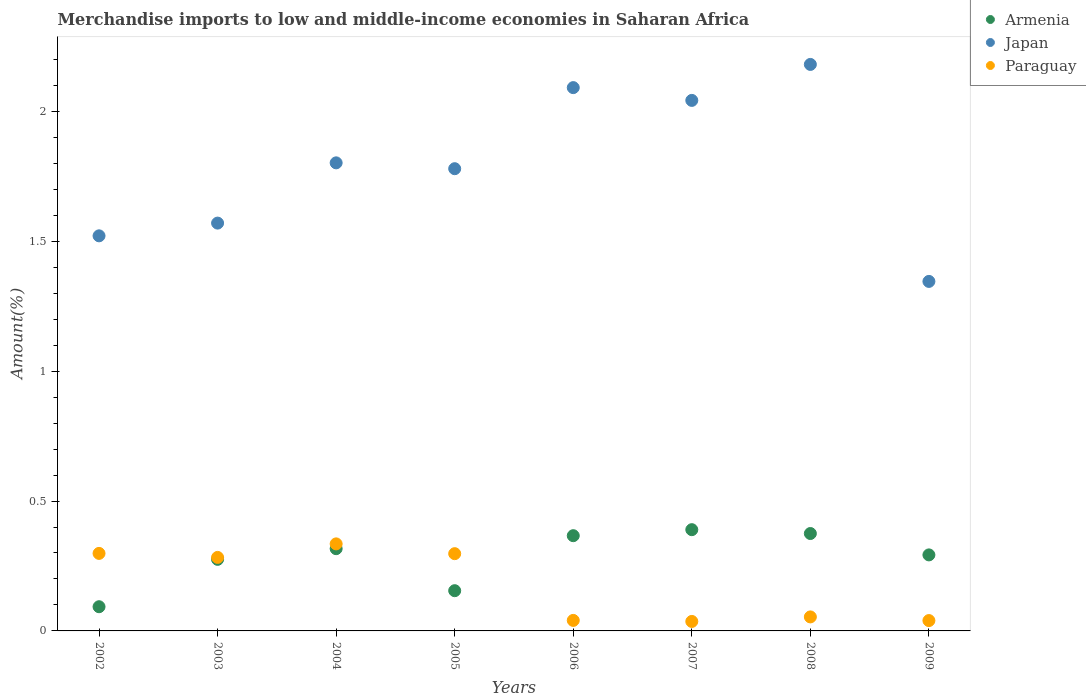What is the percentage of amount earned from merchandise imports in Armenia in 2005?
Keep it short and to the point. 0.15. Across all years, what is the maximum percentage of amount earned from merchandise imports in Armenia?
Your response must be concise. 0.39. Across all years, what is the minimum percentage of amount earned from merchandise imports in Armenia?
Ensure brevity in your answer.  0.09. In which year was the percentage of amount earned from merchandise imports in Japan maximum?
Provide a short and direct response. 2008. What is the total percentage of amount earned from merchandise imports in Armenia in the graph?
Provide a succinct answer. 2.26. What is the difference between the percentage of amount earned from merchandise imports in Armenia in 2004 and that in 2009?
Provide a short and direct response. 0.02. What is the difference between the percentage of amount earned from merchandise imports in Japan in 2004 and the percentage of amount earned from merchandise imports in Paraguay in 2003?
Ensure brevity in your answer.  1.52. What is the average percentage of amount earned from merchandise imports in Japan per year?
Offer a very short reply. 1.79. In the year 2006, what is the difference between the percentage of amount earned from merchandise imports in Japan and percentage of amount earned from merchandise imports in Armenia?
Offer a very short reply. 1.72. In how many years, is the percentage of amount earned from merchandise imports in Japan greater than 0.6 %?
Provide a short and direct response. 8. What is the ratio of the percentage of amount earned from merchandise imports in Armenia in 2002 to that in 2003?
Offer a terse response. 0.34. Is the percentage of amount earned from merchandise imports in Paraguay in 2003 less than that in 2006?
Offer a terse response. No. Is the difference between the percentage of amount earned from merchandise imports in Japan in 2004 and 2006 greater than the difference between the percentage of amount earned from merchandise imports in Armenia in 2004 and 2006?
Your answer should be compact. No. What is the difference between the highest and the second highest percentage of amount earned from merchandise imports in Japan?
Provide a short and direct response. 0.09. What is the difference between the highest and the lowest percentage of amount earned from merchandise imports in Japan?
Ensure brevity in your answer.  0.84. Is it the case that in every year, the sum of the percentage of amount earned from merchandise imports in Paraguay and percentage of amount earned from merchandise imports in Japan  is greater than the percentage of amount earned from merchandise imports in Armenia?
Ensure brevity in your answer.  Yes. Is the percentage of amount earned from merchandise imports in Japan strictly less than the percentage of amount earned from merchandise imports in Paraguay over the years?
Keep it short and to the point. No. How many years are there in the graph?
Give a very brief answer. 8. What is the title of the graph?
Offer a terse response. Merchandise imports to low and middle-income economies in Saharan Africa. What is the label or title of the Y-axis?
Ensure brevity in your answer.  Amount(%). What is the Amount(%) in Armenia in 2002?
Make the answer very short. 0.09. What is the Amount(%) in Japan in 2002?
Your answer should be compact. 1.52. What is the Amount(%) in Paraguay in 2002?
Keep it short and to the point. 0.3. What is the Amount(%) in Armenia in 2003?
Provide a short and direct response. 0.28. What is the Amount(%) in Japan in 2003?
Your answer should be compact. 1.57. What is the Amount(%) in Paraguay in 2003?
Your answer should be compact. 0.28. What is the Amount(%) in Armenia in 2004?
Offer a terse response. 0.32. What is the Amount(%) of Japan in 2004?
Provide a short and direct response. 1.8. What is the Amount(%) in Paraguay in 2004?
Your response must be concise. 0.34. What is the Amount(%) in Armenia in 2005?
Your answer should be very brief. 0.15. What is the Amount(%) in Japan in 2005?
Provide a succinct answer. 1.78. What is the Amount(%) in Paraguay in 2005?
Provide a succinct answer. 0.3. What is the Amount(%) in Armenia in 2006?
Ensure brevity in your answer.  0.37. What is the Amount(%) of Japan in 2006?
Your response must be concise. 2.09. What is the Amount(%) of Paraguay in 2006?
Your answer should be very brief. 0.04. What is the Amount(%) of Armenia in 2007?
Make the answer very short. 0.39. What is the Amount(%) in Japan in 2007?
Provide a succinct answer. 2.04. What is the Amount(%) in Paraguay in 2007?
Offer a very short reply. 0.04. What is the Amount(%) of Armenia in 2008?
Offer a terse response. 0.37. What is the Amount(%) of Japan in 2008?
Your answer should be compact. 2.18. What is the Amount(%) in Paraguay in 2008?
Provide a short and direct response. 0.05. What is the Amount(%) in Armenia in 2009?
Your answer should be very brief. 0.29. What is the Amount(%) of Japan in 2009?
Give a very brief answer. 1.35. What is the Amount(%) in Paraguay in 2009?
Give a very brief answer. 0.04. Across all years, what is the maximum Amount(%) in Armenia?
Give a very brief answer. 0.39. Across all years, what is the maximum Amount(%) in Japan?
Your answer should be very brief. 2.18. Across all years, what is the maximum Amount(%) of Paraguay?
Provide a succinct answer. 0.34. Across all years, what is the minimum Amount(%) of Armenia?
Ensure brevity in your answer.  0.09. Across all years, what is the minimum Amount(%) of Japan?
Make the answer very short. 1.35. Across all years, what is the minimum Amount(%) in Paraguay?
Provide a short and direct response. 0.04. What is the total Amount(%) of Armenia in the graph?
Provide a short and direct response. 2.26. What is the total Amount(%) in Japan in the graph?
Offer a very short reply. 14.33. What is the total Amount(%) in Paraguay in the graph?
Your answer should be compact. 1.38. What is the difference between the Amount(%) of Armenia in 2002 and that in 2003?
Your answer should be compact. -0.18. What is the difference between the Amount(%) in Japan in 2002 and that in 2003?
Give a very brief answer. -0.05. What is the difference between the Amount(%) of Paraguay in 2002 and that in 2003?
Provide a succinct answer. 0.02. What is the difference between the Amount(%) of Armenia in 2002 and that in 2004?
Your answer should be compact. -0.22. What is the difference between the Amount(%) of Japan in 2002 and that in 2004?
Offer a terse response. -0.28. What is the difference between the Amount(%) of Paraguay in 2002 and that in 2004?
Keep it short and to the point. -0.04. What is the difference between the Amount(%) in Armenia in 2002 and that in 2005?
Provide a succinct answer. -0.06. What is the difference between the Amount(%) of Japan in 2002 and that in 2005?
Keep it short and to the point. -0.26. What is the difference between the Amount(%) in Armenia in 2002 and that in 2006?
Give a very brief answer. -0.27. What is the difference between the Amount(%) of Japan in 2002 and that in 2006?
Provide a short and direct response. -0.57. What is the difference between the Amount(%) of Paraguay in 2002 and that in 2006?
Provide a short and direct response. 0.26. What is the difference between the Amount(%) of Armenia in 2002 and that in 2007?
Offer a very short reply. -0.3. What is the difference between the Amount(%) of Japan in 2002 and that in 2007?
Ensure brevity in your answer.  -0.52. What is the difference between the Amount(%) of Paraguay in 2002 and that in 2007?
Make the answer very short. 0.26. What is the difference between the Amount(%) in Armenia in 2002 and that in 2008?
Make the answer very short. -0.28. What is the difference between the Amount(%) in Japan in 2002 and that in 2008?
Make the answer very short. -0.66. What is the difference between the Amount(%) in Paraguay in 2002 and that in 2008?
Provide a succinct answer. 0.24. What is the difference between the Amount(%) in Armenia in 2002 and that in 2009?
Give a very brief answer. -0.2. What is the difference between the Amount(%) of Japan in 2002 and that in 2009?
Your answer should be compact. 0.18. What is the difference between the Amount(%) of Paraguay in 2002 and that in 2009?
Make the answer very short. 0.26. What is the difference between the Amount(%) of Armenia in 2003 and that in 2004?
Offer a terse response. -0.04. What is the difference between the Amount(%) of Japan in 2003 and that in 2004?
Your answer should be very brief. -0.23. What is the difference between the Amount(%) in Paraguay in 2003 and that in 2004?
Offer a very short reply. -0.05. What is the difference between the Amount(%) in Armenia in 2003 and that in 2005?
Keep it short and to the point. 0.12. What is the difference between the Amount(%) of Japan in 2003 and that in 2005?
Provide a short and direct response. -0.21. What is the difference between the Amount(%) of Paraguay in 2003 and that in 2005?
Your answer should be very brief. -0.01. What is the difference between the Amount(%) of Armenia in 2003 and that in 2006?
Ensure brevity in your answer.  -0.09. What is the difference between the Amount(%) of Japan in 2003 and that in 2006?
Ensure brevity in your answer.  -0.52. What is the difference between the Amount(%) in Paraguay in 2003 and that in 2006?
Ensure brevity in your answer.  0.24. What is the difference between the Amount(%) in Armenia in 2003 and that in 2007?
Keep it short and to the point. -0.11. What is the difference between the Amount(%) of Japan in 2003 and that in 2007?
Keep it short and to the point. -0.47. What is the difference between the Amount(%) in Paraguay in 2003 and that in 2007?
Give a very brief answer. 0.25. What is the difference between the Amount(%) in Armenia in 2003 and that in 2008?
Provide a short and direct response. -0.1. What is the difference between the Amount(%) of Japan in 2003 and that in 2008?
Give a very brief answer. -0.61. What is the difference between the Amount(%) in Paraguay in 2003 and that in 2008?
Give a very brief answer. 0.23. What is the difference between the Amount(%) of Armenia in 2003 and that in 2009?
Ensure brevity in your answer.  -0.02. What is the difference between the Amount(%) in Japan in 2003 and that in 2009?
Offer a very short reply. 0.22. What is the difference between the Amount(%) in Paraguay in 2003 and that in 2009?
Provide a short and direct response. 0.24. What is the difference between the Amount(%) in Armenia in 2004 and that in 2005?
Offer a terse response. 0.16. What is the difference between the Amount(%) of Japan in 2004 and that in 2005?
Your response must be concise. 0.02. What is the difference between the Amount(%) of Paraguay in 2004 and that in 2005?
Keep it short and to the point. 0.04. What is the difference between the Amount(%) in Armenia in 2004 and that in 2006?
Your answer should be very brief. -0.05. What is the difference between the Amount(%) in Japan in 2004 and that in 2006?
Provide a succinct answer. -0.29. What is the difference between the Amount(%) of Paraguay in 2004 and that in 2006?
Your answer should be compact. 0.29. What is the difference between the Amount(%) of Armenia in 2004 and that in 2007?
Provide a short and direct response. -0.07. What is the difference between the Amount(%) in Japan in 2004 and that in 2007?
Offer a terse response. -0.24. What is the difference between the Amount(%) of Paraguay in 2004 and that in 2007?
Offer a very short reply. 0.3. What is the difference between the Amount(%) of Armenia in 2004 and that in 2008?
Offer a terse response. -0.06. What is the difference between the Amount(%) in Japan in 2004 and that in 2008?
Your response must be concise. -0.38. What is the difference between the Amount(%) in Paraguay in 2004 and that in 2008?
Provide a short and direct response. 0.28. What is the difference between the Amount(%) of Armenia in 2004 and that in 2009?
Give a very brief answer. 0.02. What is the difference between the Amount(%) in Japan in 2004 and that in 2009?
Give a very brief answer. 0.46. What is the difference between the Amount(%) of Paraguay in 2004 and that in 2009?
Offer a terse response. 0.3. What is the difference between the Amount(%) in Armenia in 2005 and that in 2006?
Offer a very short reply. -0.21. What is the difference between the Amount(%) of Japan in 2005 and that in 2006?
Your answer should be very brief. -0.31. What is the difference between the Amount(%) in Paraguay in 2005 and that in 2006?
Provide a succinct answer. 0.26. What is the difference between the Amount(%) of Armenia in 2005 and that in 2007?
Keep it short and to the point. -0.23. What is the difference between the Amount(%) of Japan in 2005 and that in 2007?
Provide a short and direct response. -0.26. What is the difference between the Amount(%) of Paraguay in 2005 and that in 2007?
Make the answer very short. 0.26. What is the difference between the Amount(%) in Armenia in 2005 and that in 2008?
Give a very brief answer. -0.22. What is the difference between the Amount(%) in Japan in 2005 and that in 2008?
Make the answer very short. -0.4. What is the difference between the Amount(%) in Paraguay in 2005 and that in 2008?
Ensure brevity in your answer.  0.24. What is the difference between the Amount(%) in Armenia in 2005 and that in 2009?
Give a very brief answer. -0.14. What is the difference between the Amount(%) in Japan in 2005 and that in 2009?
Make the answer very short. 0.43. What is the difference between the Amount(%) of Paraguay in 2005 and that in 2009?
Provide a short and direct response. 0.26. What is the difference between the Amount(%) in Armenia in 2006 and that in 2007?
Offer a very short reply. -0.02. What is the difference between the Amount(%) in Japan in 2006 and that in 2007?
Provide a succinct answer. 0.05. What is the difference between the Amount(%) in Paraguay in 2006 and that in 2007?
Keep it short and to the point. 0. What is the difference between the Amount(%) in Armenia in 2006 and that in 2008?
Your response must be concise. -0.01. What is the difference between the Amount(%) of Japan in 2006 and that in 2008?
Your answer should be compact. -0.09. What is the difference between the Amount(%) in Paraguay in 2006 and that in 2008?
Ensure brevity in your answer.  -0.01. What is the difference between the Amount(%) in Armenia in 2006 and that in 2009?
Offer a terse response. 0.07. What is the difference between the Amount(%) in Japan in 2006 and that in 2009?
Ensure brevity in your answer.  0.75. What is the difference between the Amount(%) of Paraguay in 2006 and that in 2009?
Keep it short and to the point. 0. What is the difference between the Amount(%) of Armenia in 2007 and that in 2008?
Offer a very short reply. 0.01. What is the difference between the Amount(%) in Japan in 2007 and that in 2008?
Give a very brief answer. -0.14. What is the difference between the Amount(%) of Paraguay in 2007 and that in 2008?
Provide a succinct answer. -0.02. What is the difference between the Amount(%) in Armenia in 2007 and that in 2009?
Give a very brief answer. 0.1. What is the difference between the Amount(%) in Japan in 2007 and that in 2009?
Your answer should be very brief. 0.7. What is the difference between the Amount(%) in Paraguay in 2007 and that in 2009?
Ensure brevity in your answer.  -0. What is the difference between the Amount(%) of Armenia in 2008 and that in 2009?
Ensure brevity in your answer.  0.08. What is the difference between the Amount(%) in Japan in 2008 and that in 2009?
Keep it short and to the point. 0.84. What is the difference between the Amount(%) in Paraguay in 2008 and that in 2009?
Make the answer very short. 0.01. What is the difference between the Amount(%) in Armenia in 2002 and the Amount(%) in Japan in 2003?
Give a very brief answer. -1.48. What is the difference between the Amount(%) of Armenia in 2002 and the Amount(%) of Paraguay in 2003?
Provide a succinct answer. -0.19. What is the difference between the Amount(%) of Japan in 2002 and the Amount(%) of Paraguay in 2003?
Offer a very short reply. 1.24. What is the difference between the Amount(%) of Armenia in 2002 and the Amount(%) of Japan in 2004?
Make the answer very short. -1.71. What is the difference between the Amount(%) in Armenia in 2002 and the Amount(%) in Paraguay in 2004?
Offer a very short reply. -0.24. What is the difference between the Amount(%) in Japan in 2002 and the Amount(%) in Paraguay in 2004?
Your answer should be very brief. 1.19. What is the difference between the Amount(%) of Armenia in 2002 and the Amount(%) of Japan in 2005?
Your answer should be compact. -1.69. What is the difference between the Amount(%) of Armenia in 2002 and the Amount(%) of Paraguay in 2005?
Keep it short and to the point. -0.2. What is the difference between the Amount(%) in Japan in 2002 and the Amount(%) in Paraguay in 2005?
Keep it short and to the point. 1.22. What is the difference between the Amount(%) of Armenia in 2002 and the Amount(%) of Japan in 2006?
Offer a terse response. -2. What is the difference between the Amount(%) of Armenia in 2002 and the Amount(%) of Paraguay in 2006?
Offer a terse response. 0.05. What is the difference between the Amount(%) in Japan in 2002 and the Amount(%) in Paraguay in 2006?
Make the answer very short. 1.48. What is the difference between the Amount(%) in Armenia in 2002 and the Amount(%) in Japan in 2007?
Your answer should be compact. -1.95. What is the difference between the Amount(%) of Armenia in 2002 and the Amount(%) of Paraguay in 2007?
Make the answer very short. 0.06. What is the difference between the Amount(%) in Japan in 2002 and the Amount(%) in Paraguay in 2007?
Offer a very short reply. 1.48. What is the difference between the Amount(%) of Armenia in 2002 and the Amount(%) of Japan in 2008?
Provide a short and direct response. -2.09. What is the difference between the Amount(%) in Armenia in 2002 and the Amount(%) in Paraguay in 2008?
Give a very brief answer. 0.04. What is the difference between the Amount(%) in Japan in 2002 and the Amount(%) in Paraguay in 2008?
Your response must be concise. 1.47. What is the difference between the Amount(%) of Armenia in 2002 and the Amount(%) of Japan in 2009?
Your answer should be compact. -1.25. What is the difference between the Amount(%) in Armenia in 2002 and the Amount(%) in Paraguay in 2009?
Offer a terse response. 0.05. What is the difference between the Amount(%) of Japan in 2002 and the Amount(%) of Paraguay in 2009?
Offer a terse response. 1.48. What is the difference between the Amount(%) in Armenia in 2003 and the Amount(%) in Japan in 2004?
Give a very brief answer. -1.53. What is the difference between the Amount(%) in Armenia in 2003 and the Amount(%) in Paraguay in 2004?
Offer a terse response. -0.06. What is the difference between the Amount(%) of Japan in 2003 and the Amount(%) of Paraguay in 2004?
Provide a short and direct response. 1.23. What is the difference between the Amount(%) of Armenia in 2003 and the Amount(%) of Japan in 2005?
Offer a terse response. -1.5. What is the difference between the Amount(%) of Armenia in 2003 and the Amount(%) of Paraguay in 2005?
Your response must be concise. -0.02. What is the difference between the Amount(%) in Japan in 2003 and the Amount(%) in Paraguay in 2005?
Keep it short and to the point. 1.27. What is the difference between the Amount(%) of Armenia in 2003 and the Amount(%) of Japan in 2006?
Your answer should be compact. -1.82. What is the difference between the Amount(%) in Armenia in 2003 and the Amount(%) in Paraguay in 2006?
Ensure brevity in your answer.  0.23. What is the difference between the Amount(%) in Japan in 2003 and the Amount(%) in Paraguay in 2006?
Give a very brief answer. 1.53. What is the difference between the Amount(%) in Armenia in 2003 and the Amount(%) in Japan in 2007?
Offer a very short reply. -1.77. What is the difference between the Amount(%) in Armenia in 2003 and the Amount(%) in Paraguay in 2007?
Your response must be concise. 0.24. What is the difference between the Amount(%) of Japan in 2003 and the Amount(%) of Paraguay in 2007?
Your answer should be very brief. 1.53. What is the difference between the Amount(%) of Armenia in 2003 and the Amount(%) of Japan in 2008?
Your answer should be very brief. -1.91. What is the difference between the Amount(%) in Armenia in 2003 and the Amount(%) in Paraguay in 2008?
Provide a succinct answer. 0.22. What is the difference between the Amount(%) in Japan in 2003 and the Amount(%) in Paraguay in 2008?
Your answer should be compact. 1.52. What is the difference between the Amount(%) in Armenia in 2003 and the Amount(%) in Japan in 2009?
Offer a terse response. -1.07. What is the difference between the Amount(%) in Armenia in 2003 and the Amount(%) in Paraguay in 2009?
Keep it short and to the point. 0.24. What is the difference between the Amount(%) in Japan in 2003 and the Amount(%) in Paraguay in 2009?
Give a very brief answer. 1.53. What is the difference between the Amount(%) in Armenia in 2004 and the Amount(%) in Japan in 2005?
Your response must be concise. -1.46. What is the difference between the Amount(%) of Armenia in 2004 and the Amount(%) of Paraguay in 2005?
Give a very brief answer. 0.02. What is the difference between the Amount(%) in Japan in 2004 and the Amount(%) in Paraguay in 2005?
Your answer should be very brief. 1.5. What is the difference between the Amount(%) in Armenia in 2004 and the Amount(%) in Japan in 2006?
Provide a short and direct response. -1.77. What is the difference between the Amount(%) of Armenia in 2004 and the Amount(%) of Paraguay in 2006?
Offer a very short reply. 0.28. What is the difference between the Amount(%) in Japan in 2004 and the Amount(%) in Paraguay in 2006?
Ensure brevity in your answer.  1.76. What is the difference between the Amount(%) of Armenia in 2004 and the Amount(%) of Japan in 2007?
Provide a short and direct response. -1.73. What is the difference between the Amount(%) of Armenia in 2004 and the Amount(%) of Paraguay in 2007?
Keep it short and to the point. 0.28. What is the difference between the Amount(%) of Japan in 2004 and the Amount(%) of Paraguay in 2007?
Your answer should be compact. 1.77. What is the difference between the Amount(%) in Armenia in 2004 and the Amount(%) in Japan in 2008?
Make the answer very short. -1.86. What is the difference between the Amount(%) in Armenia in 2004 and the Amount(%) in Paraguay in 2008?
Your answer should be very brief. 0.26. What is the difference between the Amount(%) in Japan in 2004 and the Amount(%) in Paraguay in 2008?
Make the answer very short. 1.75. What is the difference between the Amount(%) in Armenia in 2004 and the Amount(%) in Japan in 2009?
Keep it short and to the point. -1.03. What is the difference between the Amount(%) in Armenia in 2004 and the Amount(%) in Paraguay in 2009?
Ensure brevity in your answer.  0.28. What is the difference between the Amount(%) in Japan in 2004 and the Amount(%) in Paraguay in 2009?
Your response must be concise. 1.76. What is the difference between the Amount(%) in Armenia in 2005 and the Amount(%) in Japan in 2006?
Your response must be concise. -1.94. What is the difference between the Amount(%) of Armenia in 2005 and the Amount(%) of Paraguay in 2006?
Your answer should be very brief. 0.11. What is the difference between the Amount(%) of Japan in 2005 and the Amount(%) of Paraguay in 2006?
Ensure brevity in your answer.  1.74. What is the difference between the Amount(%) in Armenia in 2005 and the Amount(%) in Japan in 2007?
Offer a terse response. -1.89. What is the difference between the Amount(%) in Armenia in 2005 and the Amount(%) in Paraguay in 2007?
Your answer should be very brief. 0.12. What is the difference between the Amount(%) in Japan in 2005 and the Amount(%) in Paraguay in 2007?
Offer a terse response. 1.74. What is the difference between the Amount(%) in Armenia in 2005 and the Amount(%) in Japan in 2008?
Your answer should be very brief. -2.03. What is the difference between the Amount(%) in Armenia in 2005 and the Amount(%) in Paraguay in 2008?
Provide a succinct answer. 0.1. What is the difference between the Amount(%) in Japan in 2005 and the Amount(%) in Paraguay in 2008?
Your answer should be compact. 1.73. What is the difference between the Amount(%) in Armenia in 2005 and the Amount(%) in Japan in 2009?
Give a very brief answer. -1.19. What is the difference between the Amount(%) in Armenia in 2005 and the Amount(%) in Paraguay in 2009?
Give a very brief answer. 0.12. What is the difference between the Amount(%) of Japan in 2005 and the Amount(%) of Paraguay in 2009?
Ensure brevity in your answer.  1.74. What is the difference between the Amount(%) in Armenia in 2006 and the Amount(%) in Japan in 2007?
Your answer should be very brief. -1.68. What is the difference between the Amount(%) of Armenia in 2006 and the Amount(%) of Paraguay in 2007?
Provide a short and direct response. 0.33. What is the difference between the Amount(%) of Japan in 2006 and the Amount(%) of Paraguay in 2007?
Offer a very short reply. 2.05. What is the difference between the Amount(%) of Armenia in 2006 and the Amount(%) of Japan in 2008?
Your response must be concise. -1.81. What is the difference between the Amount(%) of Armenia in 2006 and the Amount(%) of Paraguay in 2008?
Provide a short and direct response. 0.31. What is the difference between the Amount(%) of Japan in 2006 and the Amount(%) of Paraguay in 2008?
Give a very brief answer. 2.04. What is the difference between the Amount(%) in Armenia in 2006 and the Amount(%) in Japan in 2009?
Your answer should be very brief. -0.98. What is the difference between the Amount(%) in Armenia in 2006 and the Amount(%) in Paraguay in 2009?
Offer a very short reply. 0.33. What is the difference between the Amount(%) of Japan in 2006 and the Amount(%) of Paraguay in 2009?
Make the answer very short. 2.05. What is the difference between the Amount(%) in Armenia in 2007 and the Amount(%) in Japan in 2008?
Your answer should be very brief. -1.79. What is the difference between the Amount(%) of Armenia in 2007 and the Amount(%) of Paraguay in 2008?
Provide a succinct answer. 0.34. What is the difference between the Amount(%) in Japan in 2007 and the Amount(%) in Paraguay in 2008?
Make the answer very short. 1.99. What is the difference between the Amount(%) of Armenia in 2007 and the Amount(%) of Japan in 2009?
Offer a very short reply. -0.96. What is the difference between the Amount(%) in Armenia in 2007 and the Amount(%) in Paraguay in 2009?
Your answer should be very brief. 0.35. What is the difference between the Amount(%) in Japan in 2007 and the Amount(%) in Paraguay in 2009?
Keep it short and to the point. 2. What is the difference between the Amount(%) of Armenia in 2008 and the Amount(%) of Japan in 2009?
Offer a terse response. -0.97. What is the difference between the Amount(%) in Armenia in 2008 and the Amount(%) in Paraguay in 2009?
Provide a succinct answer. 0.34. What is the difference between the Amount(%) in Japan in 2008 and the Amount(%) in Paraguay in 2009?
Make the answer very short. 2.14. What is the average Amount(%) of Armenia per year?
Offer a terse response. 0.28. What is the average Amount(%) in Japan per year?
Provide a succinct answer. 1.79. What is the average Amount(%) in Paraguay per year?
Ensure brevity in your answer.  0.17. In the year 2002, what is the difference between the Amount(%) in Armenia and Amount(%) in Japan?
Provide a succinct answer. -1.43. In the year 2002, what is the difference between the Amount(%) of Armenia and Amount(%) of Paraguay?
Offer a terse response. -0.21. In the year 2002, what is the difference between the Amount(%) in Japan and Amount(%) in Paraguay?
Give a very brief answer. 1.22. In the year 2003, what is the difference between the Amount(%) of Armenia and Amount(%) of Japan?
Offer a terse response. -1.29. In the year 2003, what is the difference between the Amount(%) of Armenia and Amount(%) of Paraguay?
Ensure brevity in your answer.  -0.01. In the year 2003, what is the difference between the Amount(%) in Japan and Amount(%) in Paraguay?
Keep it short and to the point. 1.29. In the year 2004, what is the difference between the Amount(%) in Armenia and Amount(%) in Japan?
Your answer should be compact. -1.49. In the year 2004, what is the difference between the Amount(%) in Armenia and Amount(%) in Paraguay?
Your answer should be very brief. -0.02. In the year 2004, what is the difference between the Amount(%) of Japan and Amount(%) of Paraguay?
Provide a short and direct response. 1.47. In the year 2005, what is the difference between the Amount(%) in Armenia and Amount(%) in Japan?
Your response must be concise. -1.62. In the year 2005, what is the difference between the Amount(%) of Armenia and Amount(%) of Paraguay?
Provide a short and direct response. -0.14. In the year 2005, what is the difference between the Amount(%) in Japan and Amount(%) in Paraguay?
Offer a terse response. 1.48. In the year 2006, what is the difference between the Amount(%) of Armenia and Amount(%) of Japan?
Provide a succinct answer. -1.72. In the year 2006, what is the difference between the Amount(%) of Armenia and Amount(%) of Paraguay?
Ensure brevity in your answer.  0.33. In the year 2006, what is the difference between the Amount(%) of Japan and Amount(%) of Paraguay?
Your answer should be compact. 2.05. In the year 2007, what is the difference between the Amount(%) of Armenia and Amount(%) of Japan?
Provide a short and direct response. -1.65. In the year 2007, what is the difference between the Amount(%) of Armenia and Amount(%) of Paraguay?
Your answer should be very brief. 0.35. In the year 2007, what is the difference between the Amount(%) in Japan and Amount(%) in Paraguay?
Offer a terse response. 2.01. In the year 2008, what is the difference between the Amount(%) in Armenia and Amount(%) in Japan?
Your response must be concise. -1.81. In the year 2008, what is the difference between the Amount(%) of Armenia and Amount(%) of Paraguay?
Offer a very short reply. 0.32. In the year 2008, what is the difference between the Amount(%) in Japan and Amount(%) in Paraguay?
Give a very brief answer. 2.13. In the year 2009, what is the difference between the Amount(%) in Armenia and Amount(%) in Japan?
Ensure brevity in your answer.  -1.05. In the year 2009, what is the difference between the Amount(%) of Armenia and Amount(%) of Paraguay?
Provide a succinct answer. 0.25. In the year 2009, what is the difference between the Amount(%) in Japan and Amount(%) in Paraguay?
Make the answer very short. 1.31. What is the ratio of the Amount(%) of Armenia in 2002 to that in 2003?
Ensure brevity in your answer.  0.34. What is the ratio of the Amount(%) in Japan in 2002 to that in 2003?
Offer a terse response. 0.97. What is the ratio of the Amount(%) in Paraguay in 2002 to that in 2003?
Offer a terse response. 1.05. What is the ratio of the Amount(%) in Armenia in 2002 to that in 2004?
Ensure brevity in your answer.  0.29. What is the ratio of the Amount(%) of Japan in 2002 to that in 2004?
Provide a succinct answer. 0.84. What is the ratio of the Amount(%) of Paraguay in 2002 to that in 2004?
Offer a terse response. 0.89. What is the ratio of the Amount(%) in Armenia in 2002 to that in 2005?
Provide a succinct answer. 0.6. What is the ratio of the Amount(%) in Japan in 2002 to that in 2005?
Provide a short and direct response. 0.85. What is the ratio of the Amount(%) in Armenia in 2002 to that in 2006?
Make the answer very short. 0.25. What is the ratio of the Amount(%) of Japan in 2002 to that in 2006?
Offer a terse response. 0.73. What is the ratio of the Amount(%) in Paraguay in 2002 to that in 2006?
Keep it short and to the point. 7.38. What is the ratio of the Amount(%) in Armenia in 2002 to that in 2007?
Keep it short and to the point. 0.24. What is the ratio of the Amount(%) in Japan in 2002 to that in 2007?
Ensure brevity in your answer.  0.74. What is the ratio of the Amount(%) of Paraguay in 2002 to that in 2007?
Your answer should be very brief. 8.18. What is the ratio of the Amount(%) of Armenia in 2002 to that in 2008?
Offer a terse response. 0.25. What is the ratio of the Amount(%) of Japan in 2002 to that in 2008?
Your answer should be very brief. 0.7. What is the ratio of the Amount(%) of Paraguay in 2002 to that in 2008?
Your answer should be compact. 5.54. What is the ratio of the Amount(%) of Armenia in 2002 to that in 2009?
Give a very brief answer. 0.32. What is the ratio of the Amount(%) of Japan in 2002 to that in 2009?
Your answer should be very brief. 1.13. What is the ratio of the Amount(%) of Paraguay in 2002 to that in 2009?
Your response must be concise. 7.49. What is the ratio of the Amount(%) in Armenia in 2003 to that in 2004?
Provide a succinct answer. 0.87. What is the ratio of the Amount(%) of Japan in 2003 to that in 2004?
Make the answer very short. 0.87. What is the ratio of the Amount(%) in Paraguay in 2003 to that in 2004?
Provide a succinct answer. 0.84. What is the ratio of the Amount(%) of Armenia in 2003 to that in 2005?
Your answer should be compact. 1.78. What is the ratio of the Amount(%) of Japan in 2003 to that in 2005?
Ensure brevity in your answer.  0.88. What is the ratio of the Amount(%) of Paraguay in 2003 to that in 2005?
Provide a succinct answer. 0.95. What is the ratio of the Amount(%) in Armenia in 2003 to that in 2006?
Make the answer very short. 0.75. What is the ratio of the Amount(%) in Japan in 2003 to that in 2006?
Keep it short and to the point. 0.75. What is the ratio of the Amount(%) of Paraguay in 2003 to that in 2006?
Offer a very short reply. 6.99. What is the ratio of the Amount(%) in Armenia in 2003 to that in 2007?
Make the answer very short. 0.71. What is the ratio of the Amount(%) of Japan in 2003 to that in 2007?
Your answer should be very brief. 0.77. What is the ratio of the Amount(%) of Paraguay in 2003 to that in 2007?
Give a very brief answer. 7.76. What is the ratio of the Amount(%) of Armenia in 2003 to that in 2008?
Offer a terse response. 0.73. What is the ratio of the Amount(%) in Japan in 2003 to that in 2008?
Your answer should be very brief. 0.72. What is the ratio of the Amount(%) in Paraguay in 2003 to that in 2008?
Make the answer very short. 5.25. What is the ratio of the Amount(%) of Armenia in 2003 to that in 2009?
Offer a very short reply. 0.94. What is the ratio of the Amount(%) of Japan in 2003 to that in 2009?
Your response must be concise. 1.17. What is the ratio of the Amount(%) in Paraguay in 2003 to that in 2009?
Provide a short and direct response. 7.1. What is the ratio of the Amount(%) in Armenia in 2004 to that in 2005?
Provide a succinct answer. 2.04. What is the ratio of the Amount(%) in Japan in 2004 to that in 2005?
Keep it short and to the point. 1.01. What is the ratio of the Amount(%) in Paraguay in 2004 to that in 2005?
Your response must be concise. 1.13. What is the ratio of the Amount(%) in Armenia in 2004 to that in 2006?
Offer a terse response. 0.86. What is the ratio of the Amount(%) in Japan in 2004 to that in 2006?
Provide a succinct answer. 0.86. What is the ratio of the Amount(%) of Paraguay in 2004 to that in 2006?
Provide a succinct answer. 8.28. What is the ratio of the Amount(%) of Armenia in 2004 to that in 2007?
Your answer should be compact. 0.81. What is the ratio of the Amount(%) in Japan in 2004 to that in 2007?
Give a very brief answer. 0.88. What is the ratio of the Amount(%) of Paraguay in 2004 to that in 2007?
Make the answer very short. 9.19. What is the ratio of the Amount(%) in Armenia in 2004 to that in 2008?
Give a very brief answer. 0.84. What is the ratio of the Amount(%) in Japan in 2004 to that in 2008?
Your answer should be compact. 0.83. What is the ratio of the Amount(%) in Paraguay in 2004 to that in 2008?
Offer a terse response. 6.22. What is the ratio of the Amount(%) of Armenia in 2004 to that in 2009?
Offer a very short reply. 1.08. What is the ratio of the Amount(%) in Japan in 2004 to that in 2009?
Keep it short and to the point. 1.34. What is the ratio of the Amount(%) of Paraguay in 2004 to that in 2009?
Give a very brief answer. 8.41. What is the ratio of the Amount(%) of Armenia in 2005 to that in 2006?
Make the answer very short. 0.42. What is the ratio of the Amount(%) of Japan in 2005 to that in 2006?
Your answer should be very brief. 0.85. What is the ratio of the Amount(%) in Paraguay in 2005 to that in 2006?
Provide a succinct answer. 7.35. What is the ratio of the Amount(%) of Armenia in 2005 to that in 2007?
Offer a very short reply. 0.4. What is the ratio of the Amount(%) in Japan in 2005 to that in 2007?
Give a very brief answer. 0.87. What is the ratio of the Amount(%) in Paraguay in 2005 to that in 2007?
Make the answer very short. 8.15. What is the ratio of the Amount(%) in Armenia in 2005 to that in 2008?
Offer a terse response. 0.41. What is the ratio of the Amount(%) in Japan in 2005 to that in 2008?
Provide a short and direct response. 0.82. What is the ratio of the Amount(%) of Paraguay in 2005 to that in 2008?
Give a very brief answer. 5.52. What is the ratio of the Amount(%) of Armenia in 2005 to that in 2009?
Provide a short and direct response. 0.53. What is the ratio of the Amount(%) of Japan in 2005 to that in 2009?
Provide a short and direct response. 1.32. What is the ratio of the Amount(%) of Paraguay in 2005 to that in 2009?
Your response must be concise. 7.46. What is the ratio of the Amount(%) in Armenia in 2006 to that in 2007?
Your answer should be compact. 0.94. What is the ratio of the Amount(%) in Japan in 2006 to that in 2007?
Ensure brevity in your answer.  1.02. What is the ratio of the Amount(%) of Paraguay in 2006 to that in 2007?
Ensure brevity in your answer.  1.11. What is the ratio of the Amount(%) in Armenia in 2006 to that in 2008?
Provide a short and direct response. 0.98. What is the ratio of the Amount(%) in Japan in 2006 to that in 2008?
Keep it short and to the point. 0.96. What is the ratio of the Amount(%) of Paraguay in 2006 to that in 2008?
Offer a terse response. 0.75. What is the ratio of the Amount(%) in Armenia in 2006 to that in 2009?
Make the answer very short. 1.25. What is the ratio of the Amount(%) of Japan in 2006 to that in 2009?
Offer a terse response. 1.55. What is the ratio of the Amount(%) of Paraguay in 2006 to that in 2009?
Your answer should be compact. 1.02. What is the ratio of the Amount(%) of Armenia in 2007 to that in 2008?
Offer a terse response. 1.04. What is the ratio of the Amount(%) of Japan in 2007 to that in 2008?
Your answer should be very brief. 0.94. What is the ratio of the Amount(%) of Paraguay in 2007 to that in 2008?
Make the answer very short. 0.68. What is the ratio of the Amount(%) of Armenia in 2007 to that in 2009?
Keep it short and to the point. 1.33. What is the ratio of the Amount(%) of Japan in 2007 to that in 2009?
Provide a succinct answer. 1.52. What is the ratio of the Amount(%) of Paraguay in 2007 to that in 2009?
Ensure brevity in your answer.  0.92. What is the ratio of the Amount(%) in Armenia in 2008 to that in 2009?
Provide a short and direct response. 1.28. What is the ratio of the Amount(%) of Japan in 2008 to that in 2009?
Provide a short and direct response. 1.62. What is the ratio of the Amount(%) in Paraguay in 2008 to that in 2009?
Your answer should be very brief. 1.35. What is the difference between the highest and the second highest Amount(%) in Armenia?
Make the answer very short. 0.01. What is the difference between the highest and the second highest Amount(%) in Japan?
Your response must be concise. 0.09. What is the difference between the highest and the second highest Amount(%) in Paraguay?
Provide a succinct answer. 0.04. What is the difference between the highest and the lowest Amount(%) of Armenia?
Offer a very short reply. 0.3. What is the difference between the highest and the lowest Amount(%) in Japan?
Your answer should be compact. 0.84. What is the difference between the highest and the lowest Amount(%) of Paraguay?
Keep it short and to the point. 0.3. 